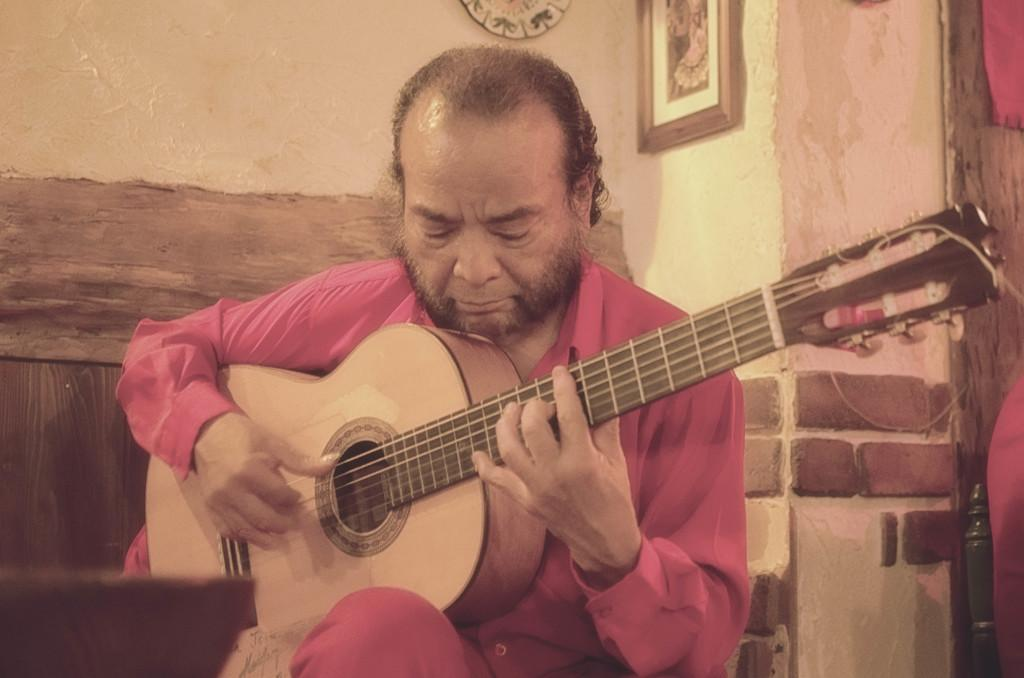What is the person in the image doing? The person in the image is playing a guitar. Can you describe the activity the person is engaged in? The person is playing a musical instrument, specifically a guitar. What can be seen in the background of the image? There is a portrait on the wall in the background. How many horses are visible in the image? There are no horses present in the image. What type of spy equipment can be seen in the image? There is no spy equipment visible in the image; it features a person playing a guitar and a portrait on the wall. 